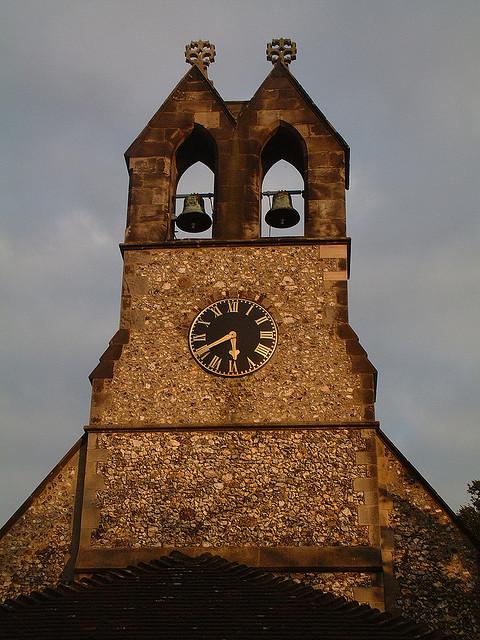How many bells are there?
Write a very short answer. 2. What time is it?
Give a very brief answer. 5:40. Where is the clock?
Keep it brief. Under bells. 